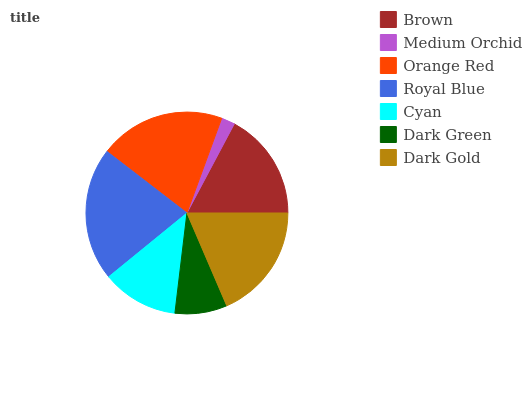Is Medium Orchid the minimum?
Answer yes or no. Yes. Is Royal Blue the maximum?
Answer yes or no. Yes. Is Orange Red the minimum?
Answer yes or no. No. Is Orange Red the maximum?
Answer yes or no. No. Is Orange Red greater than Medium Orchid?
Answer yes or no. Yes. Is Medium Orchid less than Orange Red?
Answer yes or no. Yes. Is Medium Orchid greater than Orange Red?
Answer yes or no. No. Is Orange Red less than Medium Orchid?
Answer yes or no. No. Is Brown the high median?
Answer yes or no. Yes. Is Brown the low median?
Answer yes or no. Yes. Is Dark Green the high median?
Answer yes or no. No. Is Orange Red the low median?
Answer yes or no. No. 